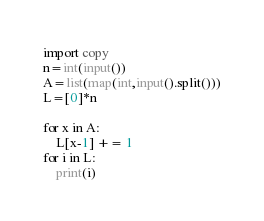<code> <loc_0><loc_0><loc_500><loc_500><_Python_>import copy
n=int(input())
A=list(map(int,input().split()))
L=[0]*n

for x in A:
    L[x-1] += 1
for i in L:
    print(i)
</code> 